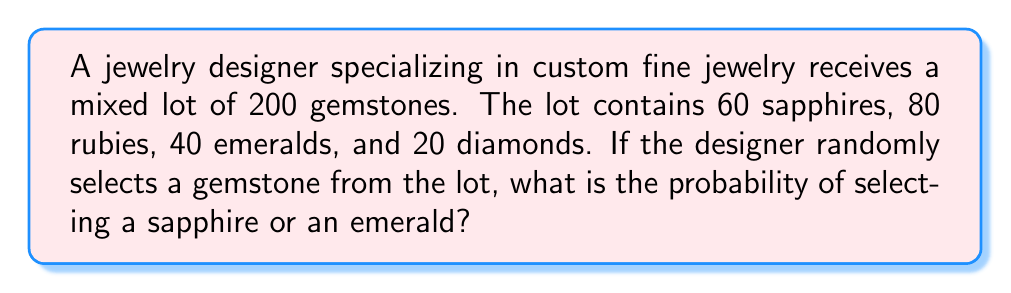What is the answer to this math problem? To solve this problem, we'll follow these steps:

1. Identify the total number of gemstones:
   Total gemstones = 200

2. Identify the number of sapphires and emeralds:
   Sapphires = 60
   Emeralds = 40

3. Calculate the probability of selecting a sapphire:
   $P(\text{Sapphire}) = \frac{\text{Number of Sapphires}}{\text{Total Gemstones}} = \frac{60}{200} = \frac{3}{10} = 0.3$

4. Calculate the probability of selecting an emerald:
   $P(\text{Emerald}) = \frac{\text{Number of Emeralds}}{\text{Total Gemstones}} = \frac{40}{200} = \frac{1}{5} = 0.2$

5. To find the probability of selecting either a sapphire or an emerald, we add these probabilities:
   $P(\text{Sapphire or Emerald}) = P(\text{Sapphire}) + P(\text{Emerald})$
   $P(\text{Sapphire or Emerald}) = \frac{3}{10} + \frac{1}{5} = \frac{6}{10} + \frac{2}{10} = \frac{8}{10} = \frac{4}{5} = 0.8$

Therefore, the probability of selecting either a sapphire or an emerald from the mixed lot is $\frac{4}{5}$ or 0.8 or 80%.
Answer: $\frac{4}{5}$ or 0.8 or 80% 